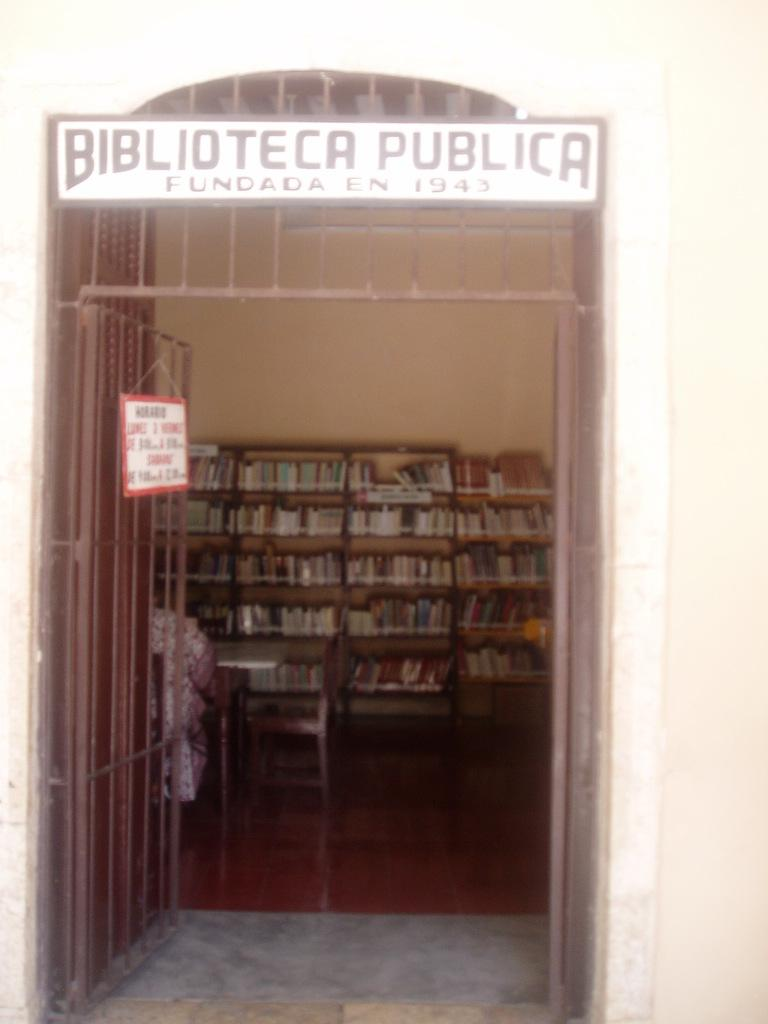<image>
Share a concise interpretation of the image provided. A sign above an open door reading Biblioteca Publica. 